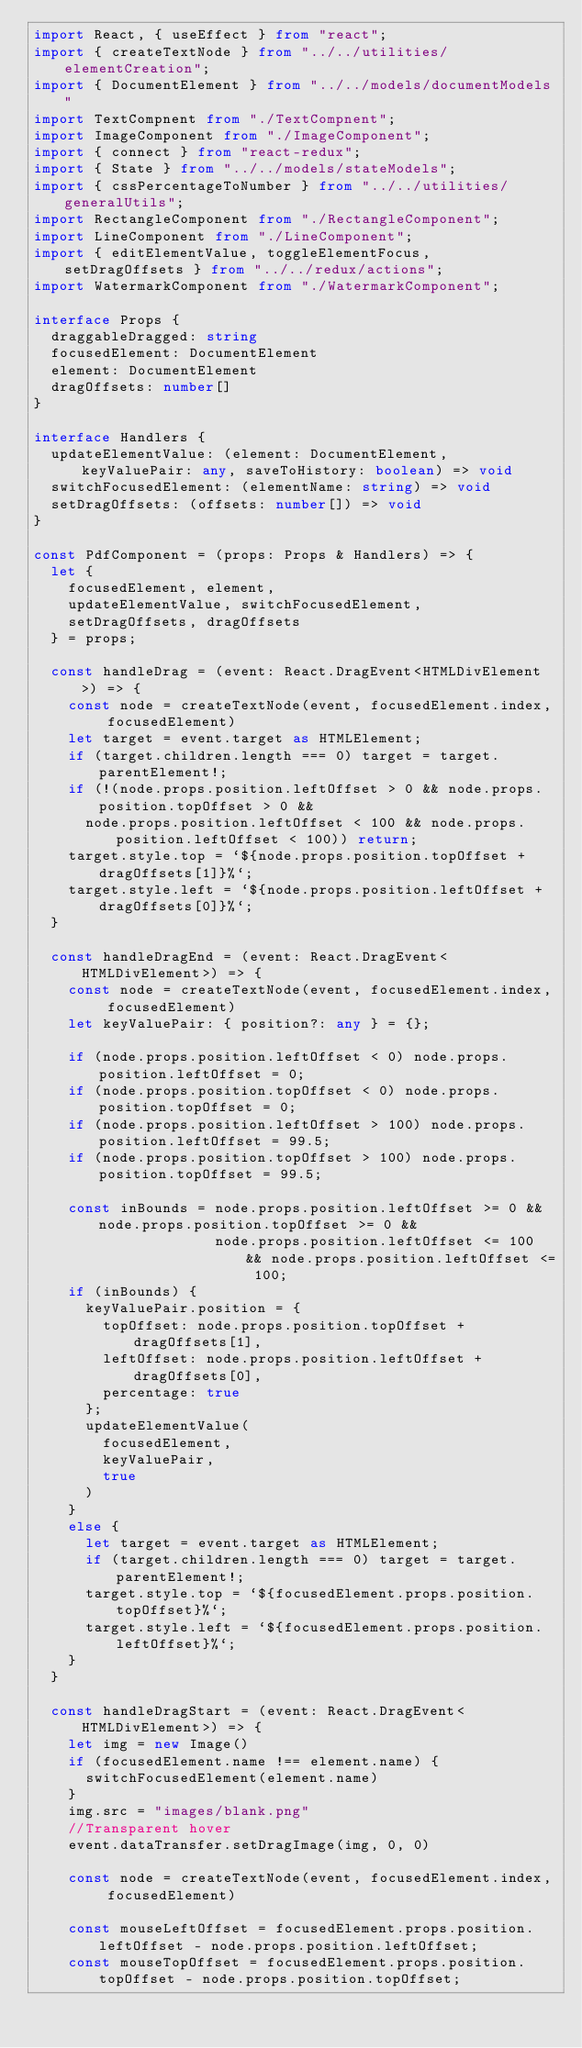<code> <loc_0><loc_0><loc_500><loc_500><_TypeScript_>import React, { useEffect } from "react";
import { createTextNode } from "../../utilities/elementCreation";
import { DocumentElement } from "../../models/documentModels"
import TextCompnent from "./TextCompnent";
import ImageComponent from "./ImageComponent";
import { connect } from "react-redux";
import { State } from "../../models/stateModels";
import { cssPercentageToNumber } from "../../utilities/generalUtils";
import RectangleComponent from "./RectangleComponent";
import LineComponent from "./LineComponent";
import { editElementValue, toggleElementFocus, setDragOffsets } from "../../redux/actions";
import WatermarkComponent from "./WatermarkComponent";

interface Props {
  draggableDragged: string
  focusedElement: DocumentElement
  element: DocumentElement
  dragOffsets: number[]
}

interface Handlers {
  updateElementValue: (element: DocumentElement, keyValuePair: any, saveToHistory: boolean) => void
  switchFocusedElement: (elementName: string) => void
  setDragOffsets: (offsets: number[]) => void
}

const PdfComponent = (props: Props & Handlers) => {
  let {
    focusedElement, element,
    updateElementValue, switchFocusedElement,
    setDragOffsets, dragOffsets
  } = props;

  const handleDrag = (event: React.DragEvent<HTMLDivElement>) => {
    const node = createTextNode(event, focusedElement.index, focusedElement)
    let target = event.target as HTMLElement;
    if (target.children.length === 0) target = target.parentElement!;
    if (!(node.props.position.leftOffset > 0 && node.props.position.topOffset > 0 &&
      node.props.position.leftOffset < 100 && node.props.position.leftOffset < 100)) return;
    target.style.top = `${node.props.position.topOffset + dragOffsets[1]}%`;
    target.style.left = `${node.props.position.leftOffset + dragOffsets[0]}%`;
  }

  const handleDragEnd = (event: React.DragEvent<HTMLDivElement>) => {
    const node = createTextNode(event, focusedElement.index, focusedElement)
    let keyValuePair: { position?: any } = {};

    if (node.props.position.leftOffset < 0) node.props.position.leftOffset = 0;
    if (node.props.position.topOffset < 0) node.props.position.topOffset = 0;
    if (node.props.position.leftOffset > 100) node.props.position.leftOffset = 99.5;
    if (node.props.position.topOffset > 100) node.props.position.topOffset = 99.5;

    const inBounds = node.props.position.leftOffset >= 0 && node.props.position.topOffset >= 0 &&
                     node.props.position.leftOffset <= 100 && node.props.position.leftOffset <= 100;
    if (inBounds) {
      keyValuePair.position = {
        topOffset: node.props.position.topOffset + dragOffsets[1],
        leftOffset: node.props.position.leftOffset + dragOffsets[0],
        percentage: true
      };
      updateElementValue(
        focusedElement,
        keyValuePair,
        true
      )
    }
    else {
      let target = event.target as HTMLElement;
      if (target.children.length === 0) target = target.parentElement!;
      target.style.top = `${focusedElement.props.position.topOffset}%`;
      target.style.left = `${focusedElement.props.position.leftOffset}%`;
    }
  }

  const handleDragStart = (event: React.DragEvent<HTMLDivElement>) => {
    let img = new Image()
    if (focusedElement.name !== element.name) {
      switchFocusedElement(element.name)
    }
    img.src = "images/blank.png"
    //Transparent hover
    event.dataTransfer.setDragImage(img, 0, 0)

    const node = createTextNode(event, focusedElement.index, focusedElement)

    const mouseLeftOffset = focusedElement.props.position.leftOffset - node.props.position.leftOffset;
    const mouseTopOffset = focusedElement.props.position.topOffset - node.props.position.topOffset;</code> 